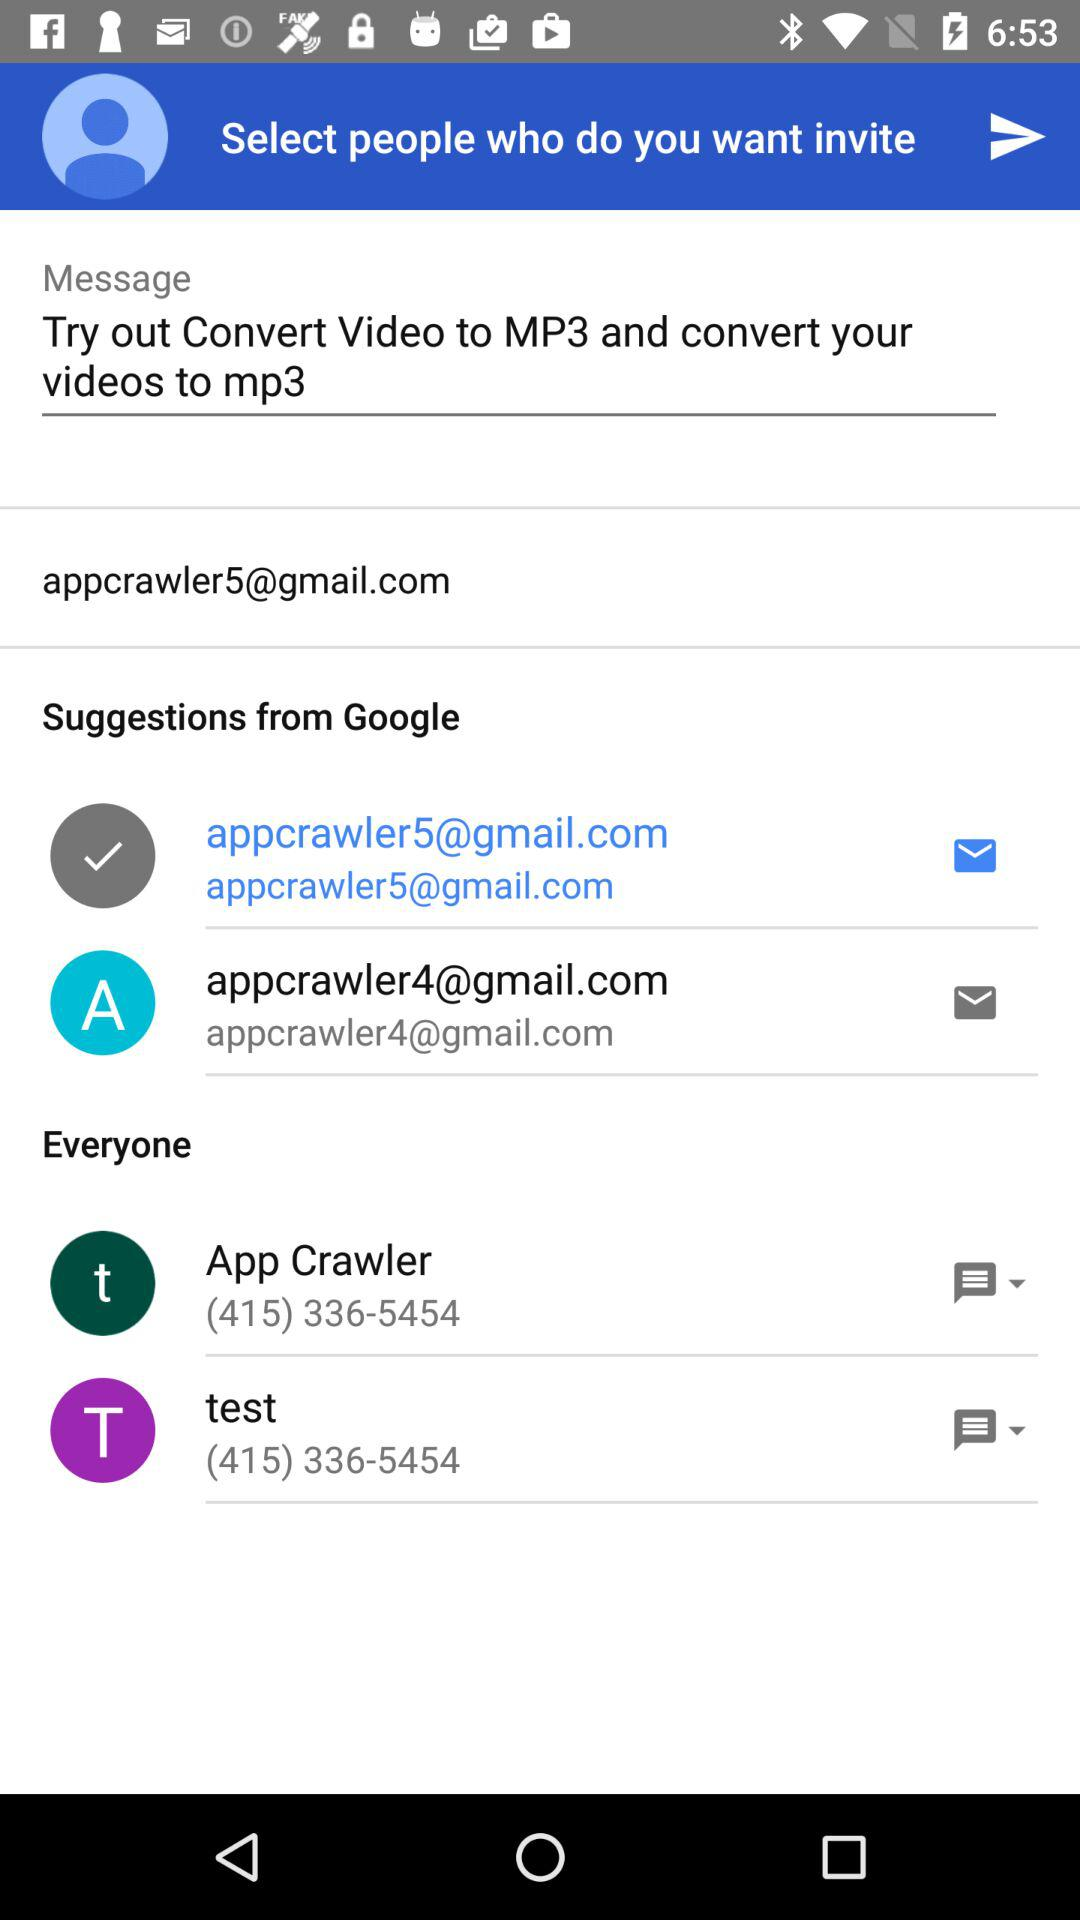What is the contact number of App Crawler? The contact number of App Crawler is (415) 336-5454. 